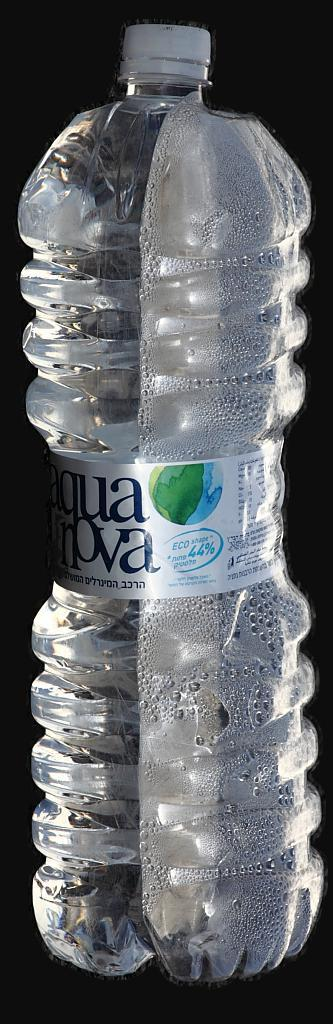What object is present in the picture that can hold liquid? There is a water bottle in the picture. Can you describe the appearance of the water bottle? The water bottle is transparent. What can be seen inside the water bottle? There is water visible inside the water bottle. What is used to seal the water bottle? There is a cap in the picture. What riddle is written on the water bottle in the image? There is no riddle written on the water bottle in the image; it is simply a transparent water bottle with water inside and a cap. 